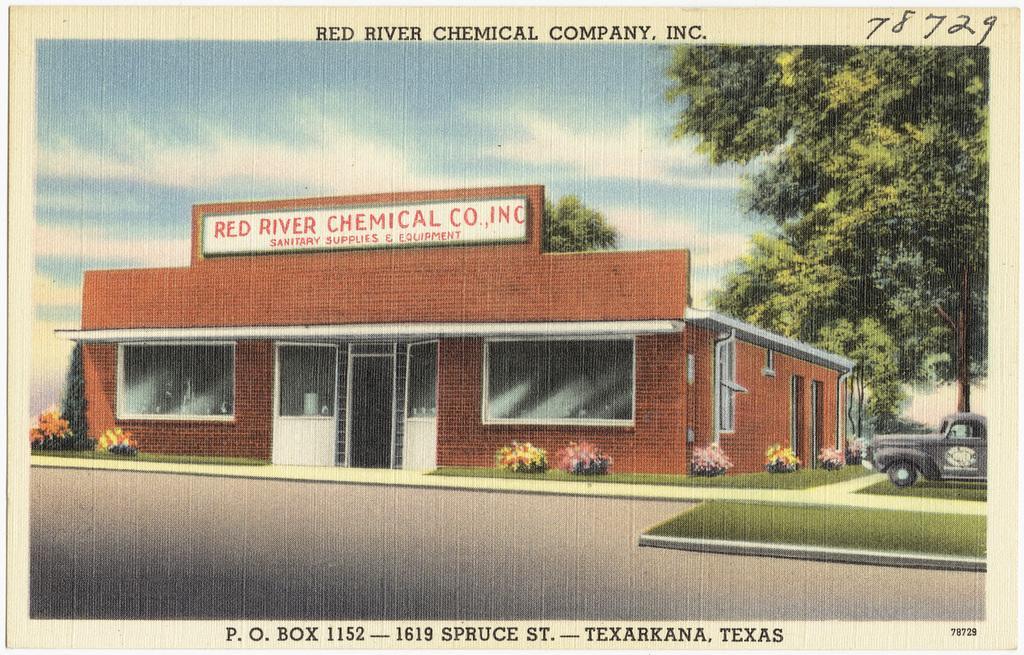How would you summarize this image in a sentence or two? In this image, we can see a poster, on that poster we can see a house and a car, there are some plants and trees, at the top there is a sky and we can see the road. 